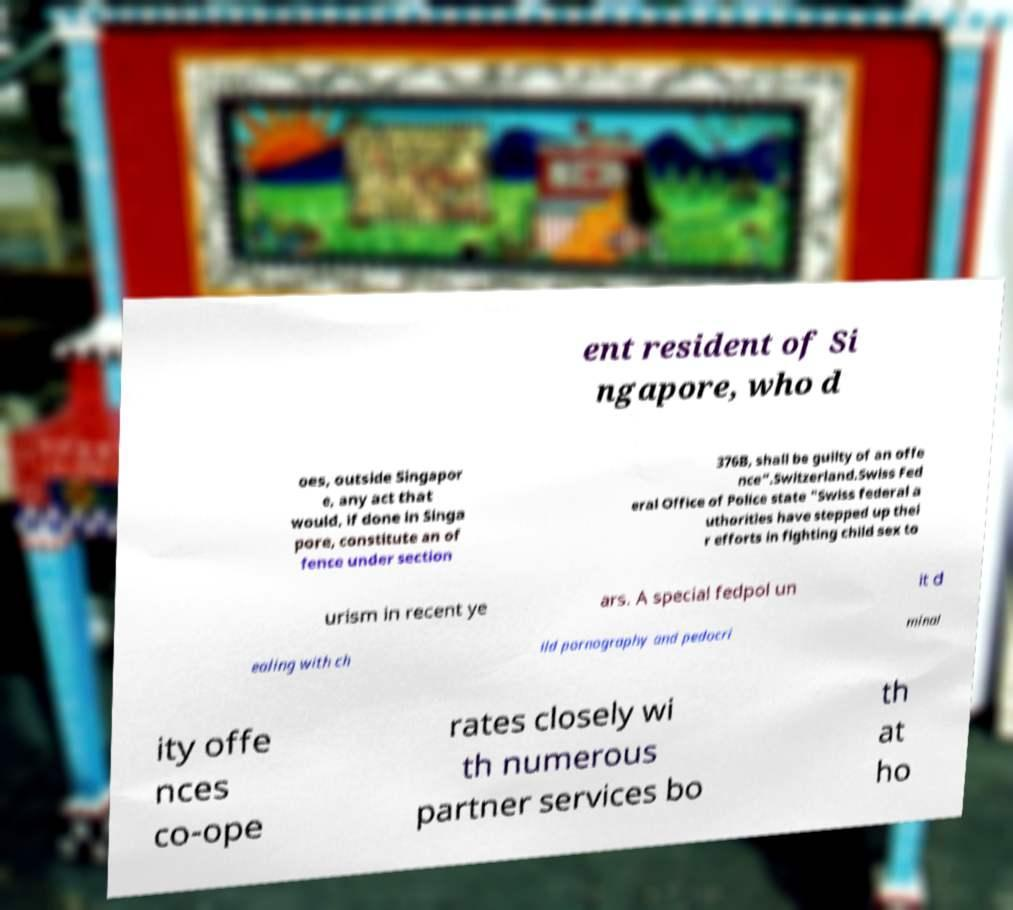Can you accurately transcribe the text from the provided image for me? ent resident of Si ngapore, who d oes, outside Singapor e, any act that would, if done in Singa pore, constitute an of fence under section 376B, shall be guilty of an offe nce".Switzerland.Swiss Fed eral Office of Police state "Swiss federal a uthorities have stepped up thei r efforts in fighting child sex to urism in recent ye ars. A special fedpol un it d ealing with ch ild pornography and pedocri minal ity offe nces co-ope rates closely wi th numerous partner services bo th at ho 